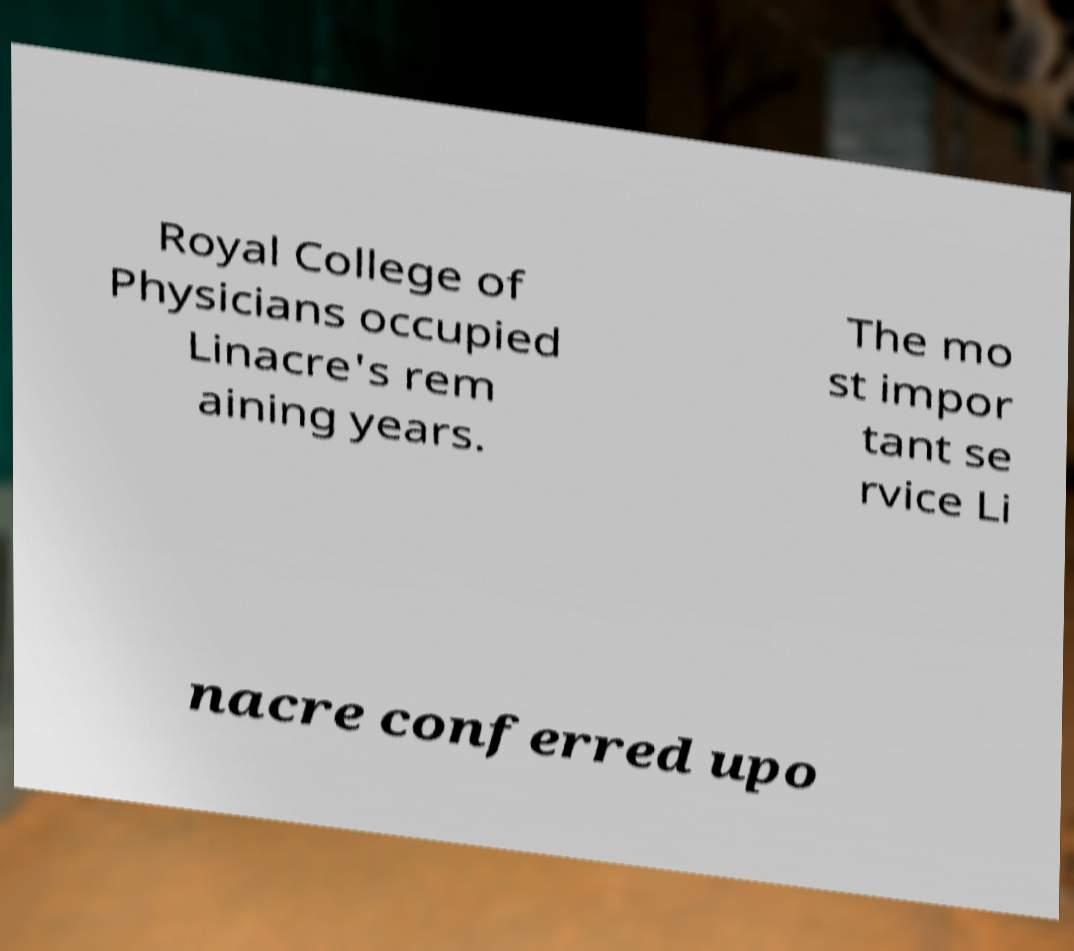What messages or text are displayed in this image? I need them in a readable, typed format. Royal College of Physicians occupied Linacre's rem aining years. The mo st impor tant se rvice Li nacre conferred upo 